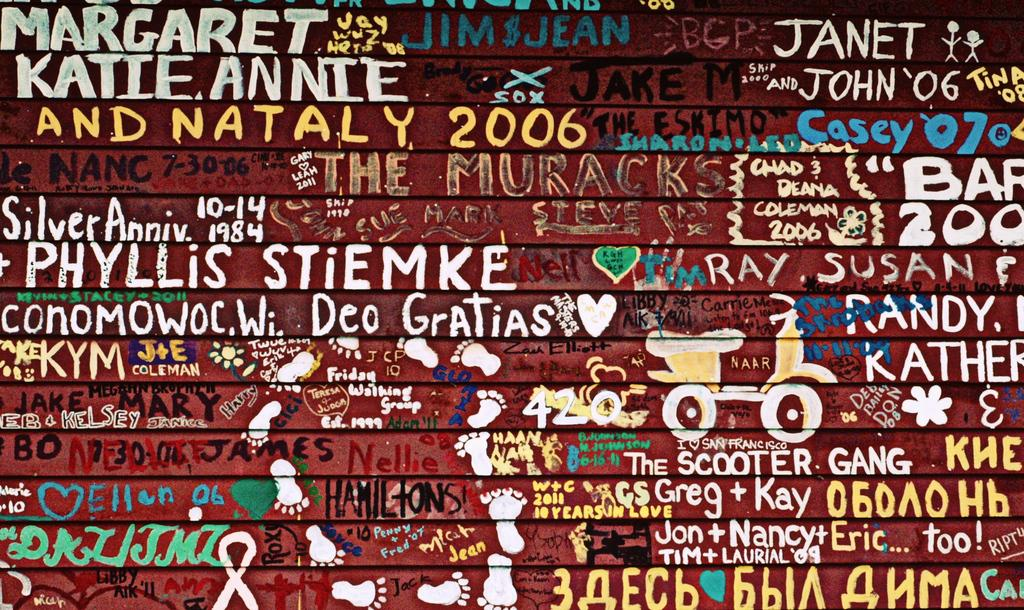<image>
Render a clear and concise summary of the photo. A poster showing various graffiti on a wall mostly made up of names like Margaret, Phyllis and Janet. 